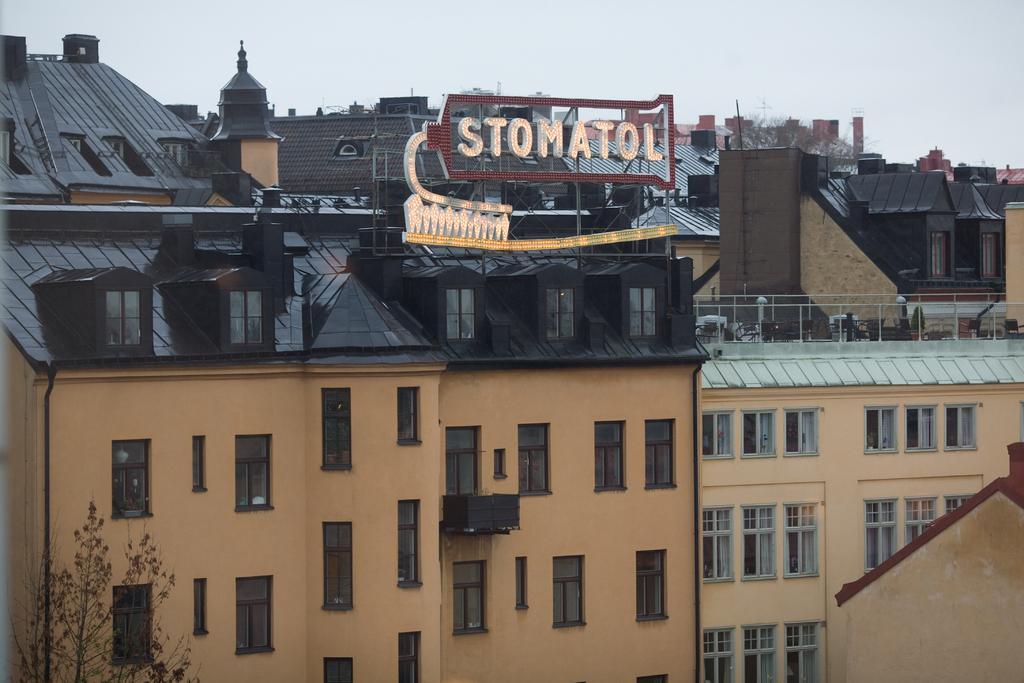How would you summarize this image in a sentence or two? In this picture we can observe some buildings with black color roofs. We can observe dried trees here. In the background there is a sky. 